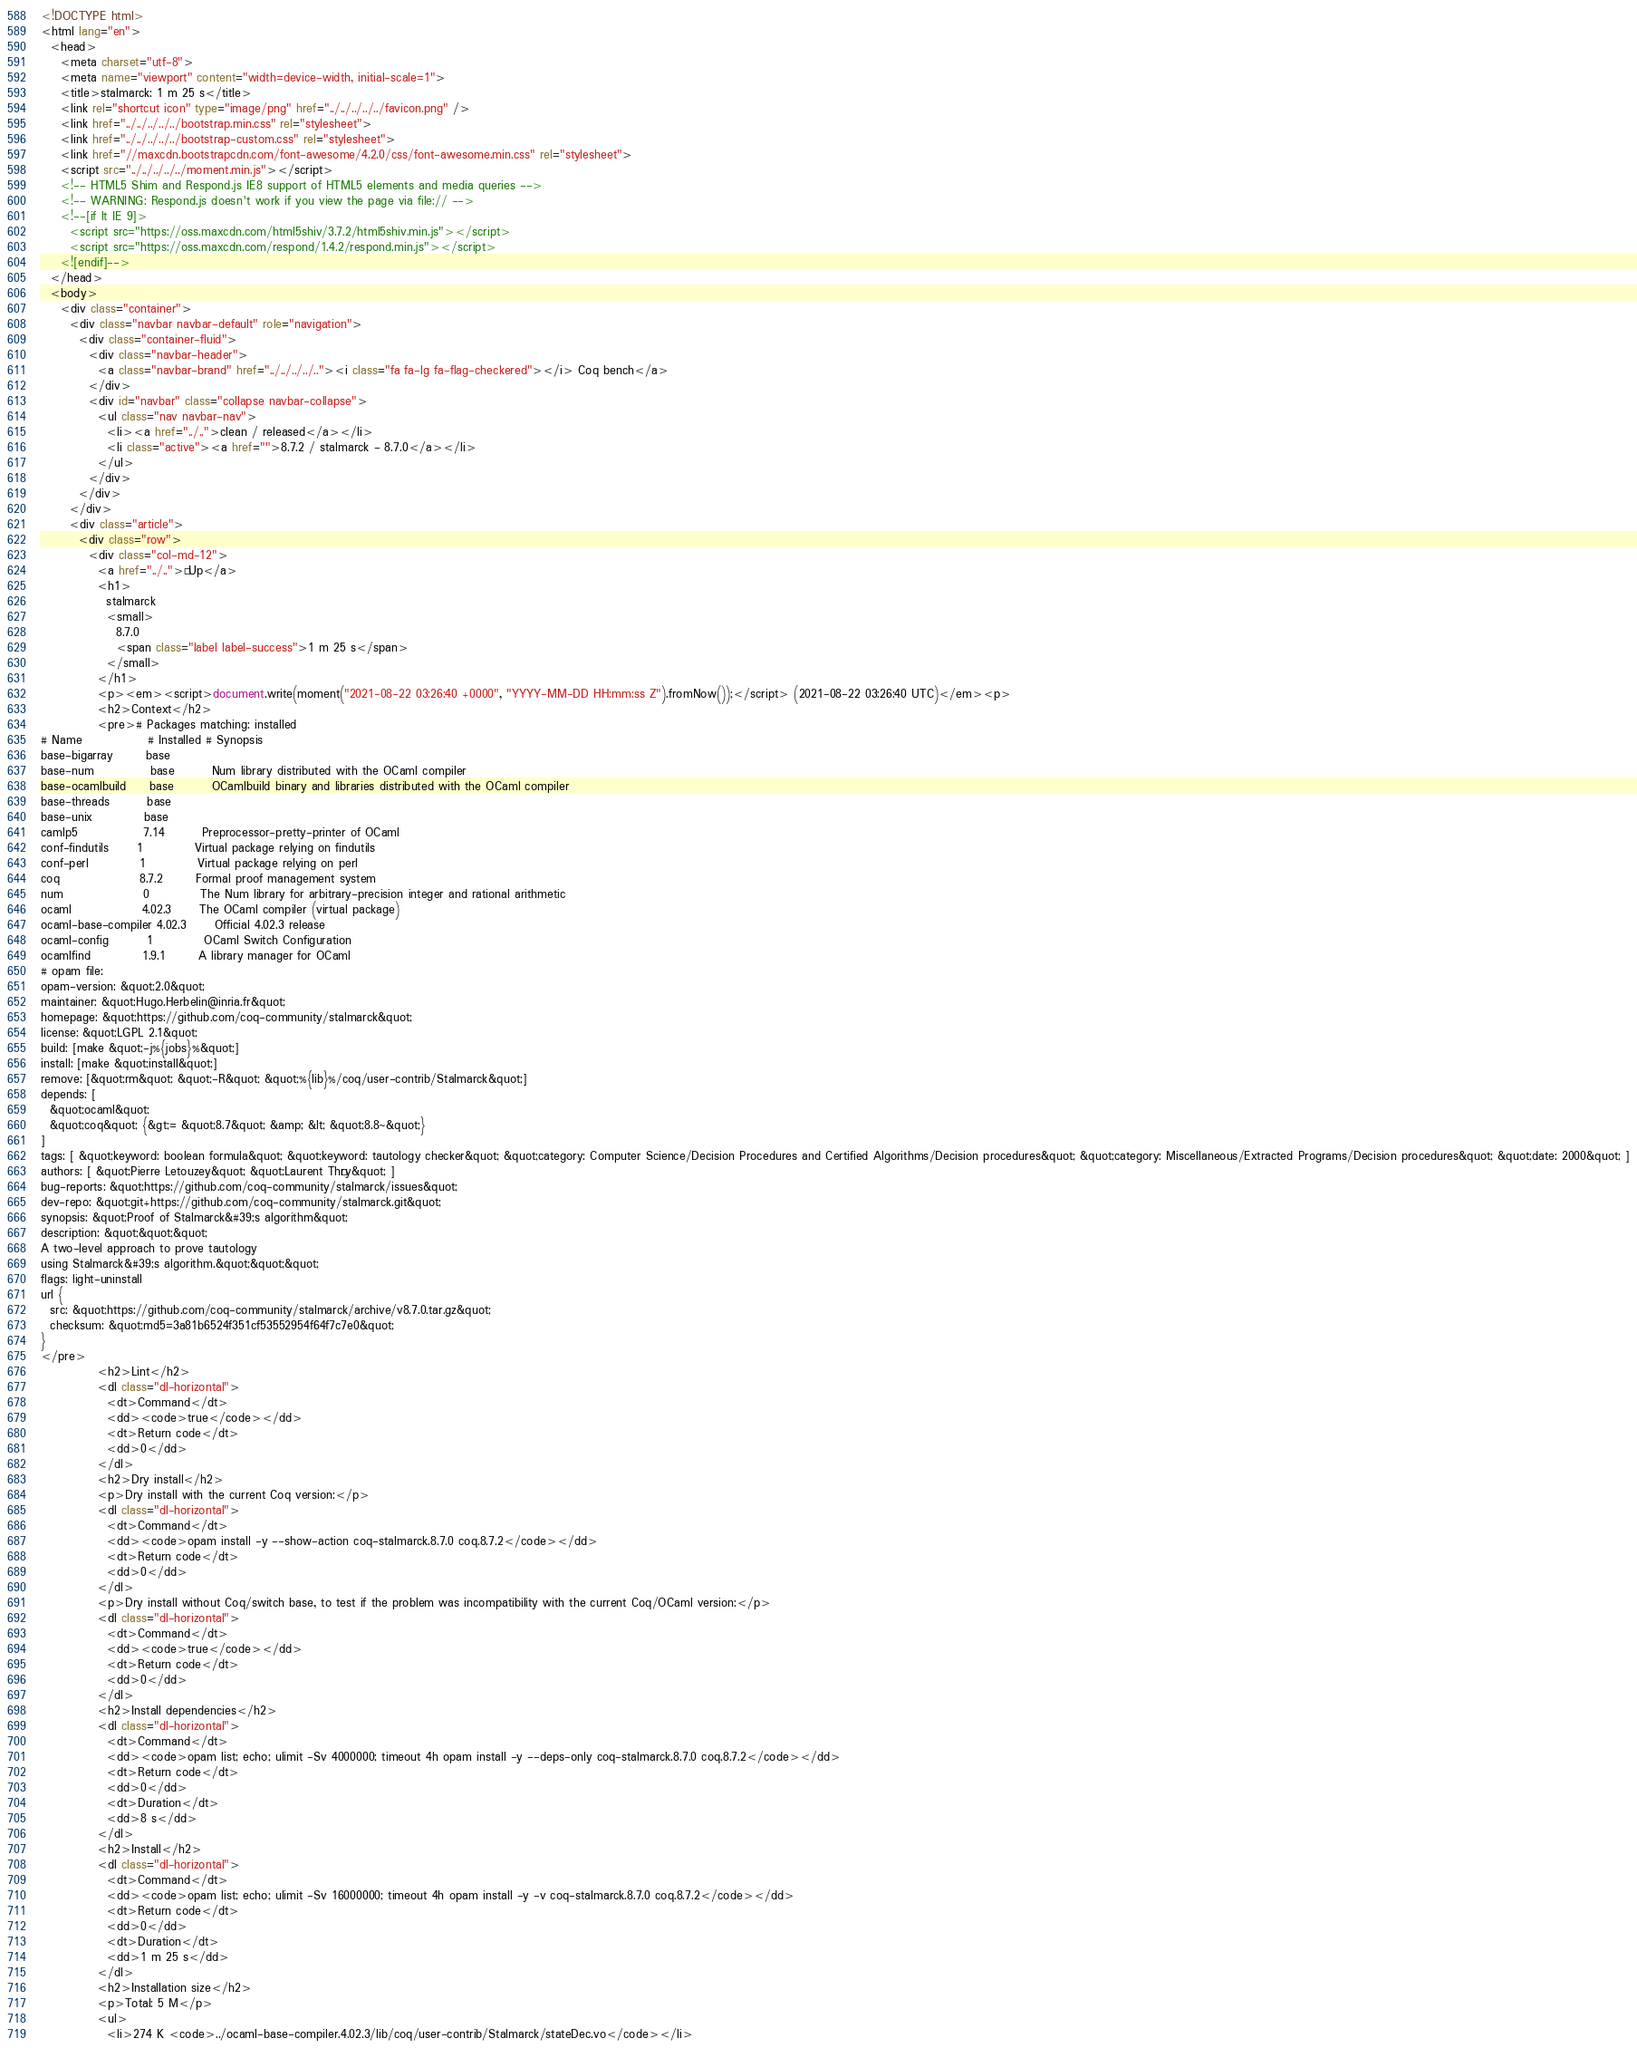<code> <loc_0><loc_0><loc_500><loc_500><_HTML_><!DOCTYPE html>
<html lang="en">
  <head>
    <meta charset="utf-8">
    <meta name="viewport" content="width=device-width, initial-scale=1">
    <title>stalmarck: 1 m 25 s</title>
    <link rel="shortcut icon" type="image/png" href="../../../../../favicon.png" />
    <link href="../../../../../bootstrap.min.css" rel="stylesheet">
    <link href="../../../../../bootstrap-custom.css" rel="stylesheet">
    <link href="//maxcdn.bootstrapcdn.com/font-awesome/4.2.0/css/font-awesome.min.css" rel="stylesheet">
    <script src="../../../../../moment.min.js"></script>
    <!-- HTML5 Shim and Respond.js IE8 support of HTML5 elements and media queries -->
    <!-- WARNING: Respond.js doesn't work if you view the page via file:// -->
    <!--[if lt IE 9]>
      <script src="https://oss.maxcdn.com/html5shiv/3.7.2/html5shiv.min.js"></script>
      <script src="https://oss.maxcdn.com/respond/1.4.2/respond.min.js"></script>
    <![endif]-->
  </head>
  <body>
    <div class="container">
      <div class="navbar navbar-default" role="navigation">
        <div class="container-fluid">
          <div class="navbar-header">
            <a class="navbar-brand" href="../../../../.."><i class="fa fa-lg fa-flag-checkered"></i> Coq bench</a>
          </div>
          <div id="navbar" class="collapse navbar-collapse">
            <ul class="nav navbar-nav">
              <li><a href="../..">clean / released</a></li>
              <li class="active"><a href="">8.7.2 / stalmarck - 8.7.0</a></li>
            </ul>
          </div>
        </div>
      </div>
      <div class="article">
        <div class="row">
          <div class="col-md-12">
            <a href="../..">« Up</a>
            <h1>
              stalmarck
              <small>
                8.7.0
                <span class="label label-success">1 m 25 s</span>
              </small>
            </h1>
            <p><em><script>document.write(moment("2021-08-22 03:26:40 +0000", "YYYY-MM-DD HH:mm:ss Z").fromNow());</script> (2021-08-22 03:26:40 UTC)</em><p>
            <h2>Context</h2>
            <pre># Packages matching: installed
# Name              # Installed # Synopsis
base-bigarray       base
base-num            base        Num library distributed with the OCaml compiler
base-ocamlbuild     base        OCamlbuild binary and libraries distributed with the OCaml compiler
base-threads        base
base-unix           base
camlp5              7.14        Preprocessor-pretty-printer of OCaml
conf-findutils      1           Virtual package relying on findutils
conf-perl           1           Virtual package relying on perl
coq                 8.7.2       Formal proof management system
num                 0           The Num library for arbitrary-precision integer and rational arithmetic
ocaml               4.02.3      The OCaml compiler (virtual package)
ocaml-base-compiler 4.02.3      Official 4.02.3 release
ocaml-config        1           OCaml Switch Configuration
ocamlfind           1.9.1       A library manager for OCaml
# opam file:
opam-version: &quot;2.0&quot;
maintainer: &quot;Hugo.Herbelin@inria.fr&quot;
homepage: &quot;https://github.com/coq-community/stalmarck&quot;
license: &quot;LGPL 2.1&quot;
build: [make &quot;-j%{jobs}%&quot;]
install: [make &quot;install&quot;]
remove: [&quot;rm&quot; &quot;-R&quot; &quot;%{lib}%/coq/user-contrib/Stalmarck&quot;]
depends: [
  &quot;ocaml&quot;
  &quot;coq&quot; {&gt;= &quot;8.7&quot; &amp; &lt; &quot;8.8~&quot;}
]
tags: [ &quot;keyword: boolean formula&quot; &quot;keyword: tautology checker&quot; &quot;category: Computer Science/Decision Procedures and Certified Algorithms/Decision procedures&quot; &quot;category: Miscellaneous/Extracted Programs/Decision procedures&quot; &quot;date: 2000&quot; ]
authors: [ &quot;Pierre Letouzey&quot; &quot;Laurent Théry&quot; ]
bug-reports: &quot;https://github.com/coq-community/stalmarck/issues&quot;
dev-repo: &quot;git+https://github.com/coq-community/stalmarck.git&quot;
synopsis: &quot;Proof of Stalmarck&#39;s algorithm&quot;
description: &quot;&quot;&quot;
A two-level approach to prove tautology
using Stalmarck&#39;s algorithm.&quot;&quot;&quot;
flags: light-uninstall
url {
  src: &quot;https://github.com/coq-community/stalmarck/archive/v8.7.0.tar.gz&quot;
  checksum: &quot;md5=3a81b6524f351cf53552954f64f7c7e0&quot;
}
</pre>
            <h2>Lint</h2>
            <dl class="dl-horizontal">
              <dt>Command</dt>
              <dd><code>true</code></dd>
              <dt>Return code</dt>
              <dd>0</dd>
            </dl>
            <h2>Dry install</h2>
            <p>Dry install with the current Coq version:</p>
            <dl class="dl-horizontal">
              <dt>Command</dt>
              <dd><code>opam install -y --show-action coq-stalmarck.8.7.0 coq.8.7.2</code></dd>
              <dt>Return code</dt>
              <dd>0</dd>
            </dl>
            <p>Dry install without Coq/switch base, to test if the problem was incompatibility with the current Coq/OCaml version:</p>
            <dl class="dl-horizontal">
              <dt>Command</dt>
              <dd><code>true</code></dd>
              <dt>Return code</dt>
              <dd>0</dd>
            </dl>
            <h2>Install dependencies</h2>
            <dl class="dl-horizontal">
              <dt>Command</dt>
              <dd><code>opam list; echo; ulimit -Sv 4000000; timeout 4h opam install -y --deps-only coq-stalmarck.8.7.0 coq.8.7.2</code></dd>
              <dt>Return code</dt>
              <dd>0</dd>
              <dt>Duration</dt>
              <dd>8 s</dd>
            </dl>
            <h2>Install</h2>
            <dl class="dl-horizontal">
              <dt>Command</dt>
              <dd><code>opam list; echo; ulimit -Sv 16000000; timeout 4h opam install -y -v coq-stalmarck.8.7.0 coq.8.7.2</code></dd>
              <dt>Return code</dt>
              <dd>0</dd>
              <dt>Duration</dt>
              <dd>1 m 25 s</dd>
            </dl>
            <h2>Installation size</h2>
            <p>Total: 5 M</p>
            <ul>
              <li>274 K <code>../ocaml-base-compiler.4.02.3/lib/coq/user-contrib/Stalmarck/stateDec.vo</code></li></code> 